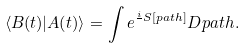Convert formula to latex. <formula><loc_0><loc_0><loc_500><loc_500>\langle B ( t ) | A ( t ) \rangle = \int e ^ { \frac { i } { } S [ p a t h ] } D p a t h .</formula> 